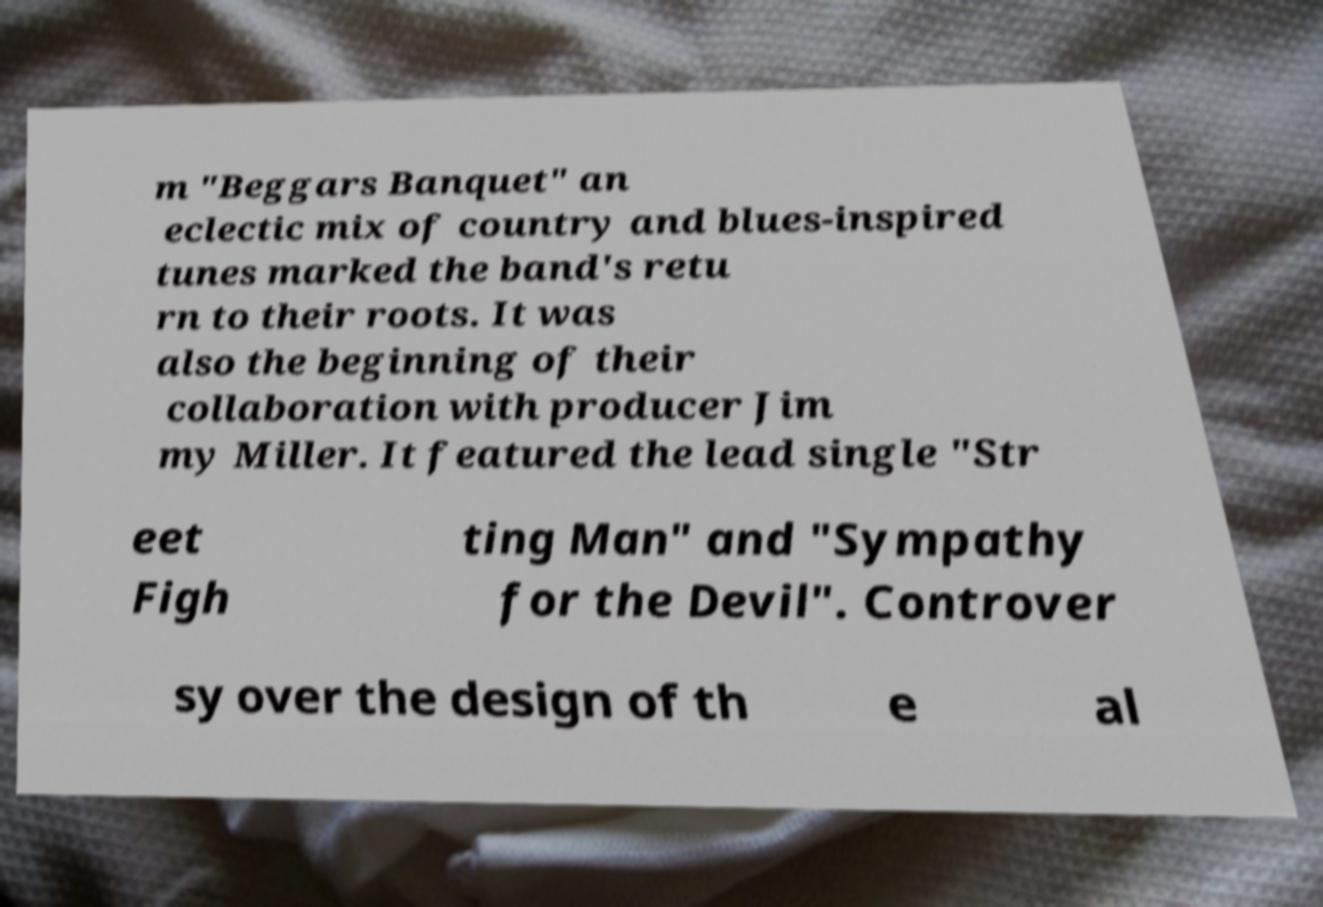Can you accurately transcribe the text from the provided image for me? m "Beggars Banquet" an eclectic mix of country and blues-inspired tunes marked the band's retu rn to their roots. It was also the beginning of their collaboration with producer Jim my Miller. It featured the lead single "Str eet Figh ting Man" and "Sympathy for the Devil". Controver sy over the design of th e al 